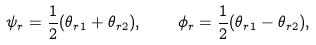<formula> <loc_0><loc_0><loc_500><loc_500>\psi _ { r } = \frac { 1 } { 2 } ( \theta _ { r 1 } + \theta _ { r 2 } ) , \quad \phi _ { r } = \frac { 1 } { 2 } ( \theta _ { r 1 } - \theta _ { r 2 } ) ,</formula> 